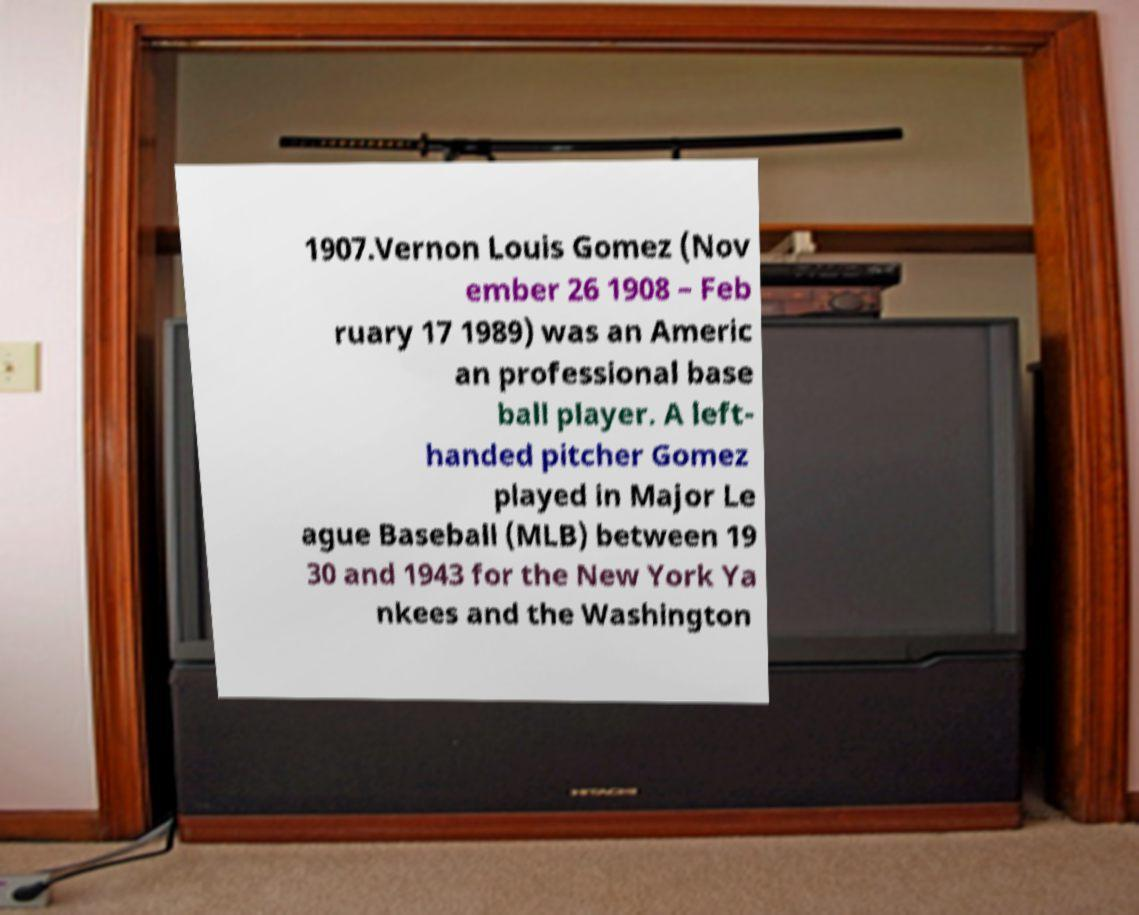Please identify and transcribe the text found in this image. 1907.Vernon Louis Gomez (Nov ember 26 1908 – Feb ruary 17 1989) was an Americ an professional base ball player. A left- handed pitcher Gomez played in Major Le ague Baseball (MLB) between 19 30 and 1943 for the New York Ya nkees and the Washington 